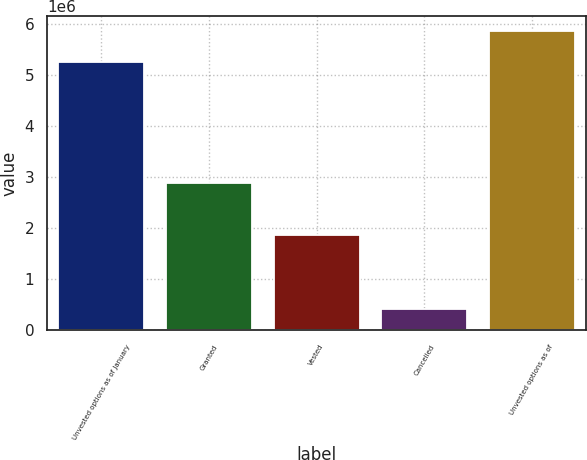<chart> <loc_0><loc_0><loc_500><loc_500><bar_chart><fcel>Unvested options as of January<fcel>Granted<fcel>Vested<fcel>Cancelled<fcel>Unvested options as of<nl><fcel>5.25093e+06<fcel>2.88975e+06<fcel>1.86498e+06<fcel>410864<fcel>5.86483e+06<nl></chart> 